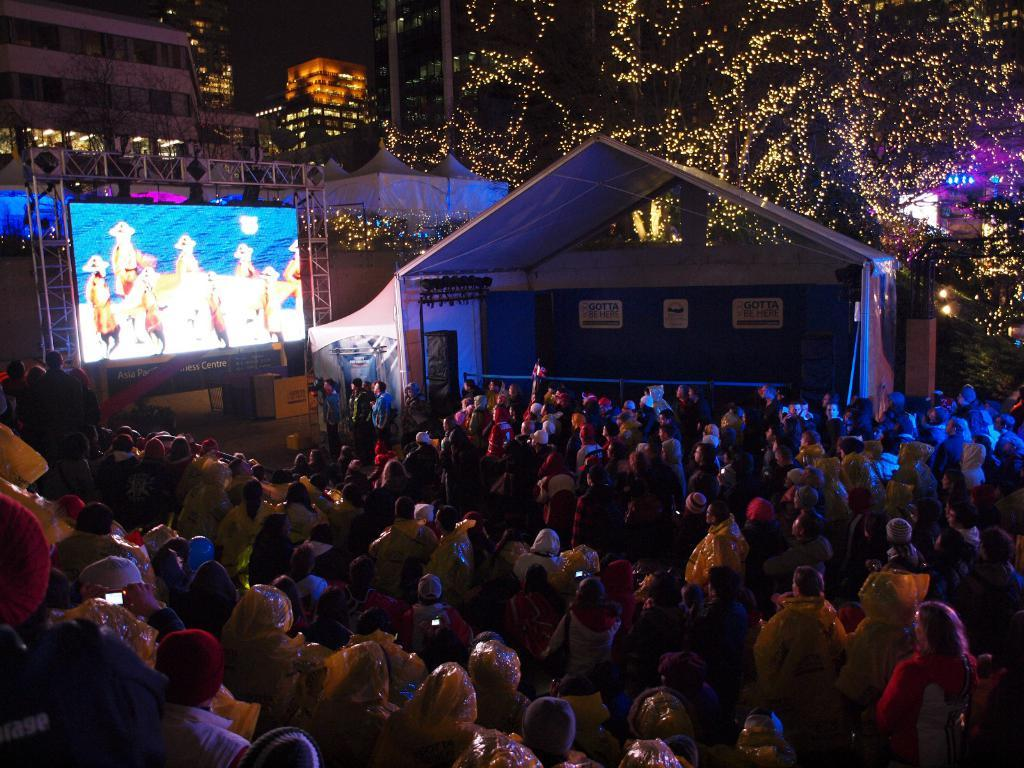What are the persons in the image doing? The persons in the image are on the ground. What is in front of the persons? There is a screen in front of the persons. What can be seen in the background of the image? There are buildings and lights arranged in the background. How would you describe the color of the background? The background is dark in color. What song is being sung by the persons in the image? There is no indication in the image that the persons are singing a song, so it cannot be determined from the picture. 